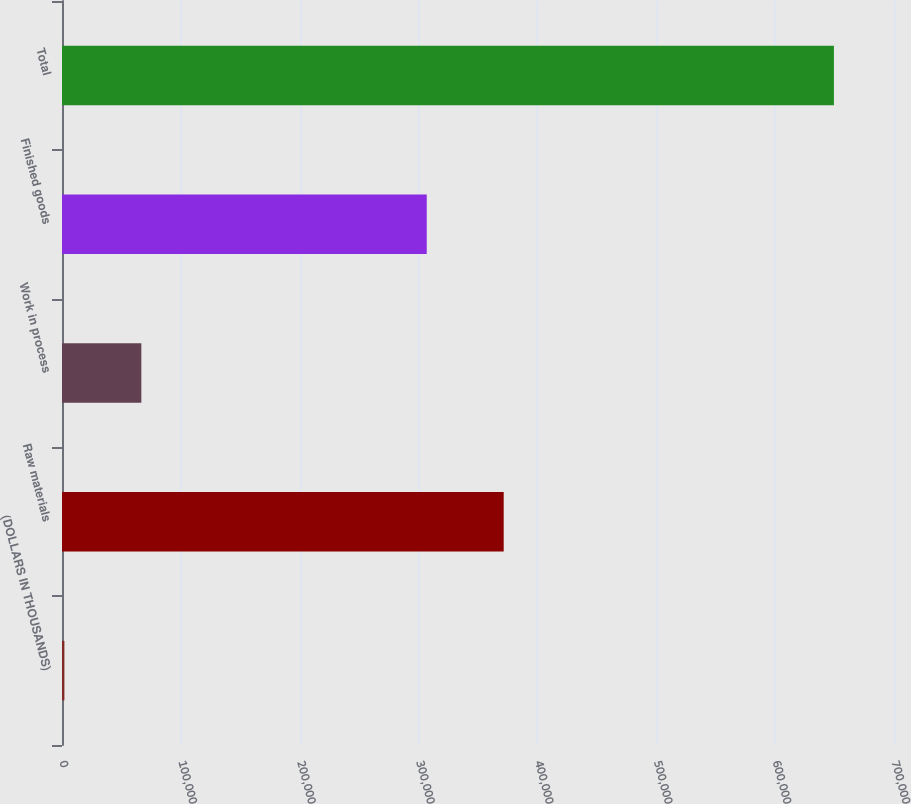<chart> <loc_0><loc_0><loc_500><loc_500><bar_chart><fcel>(DOLLARS IN THOUSANDS)<fcel>Raw materials<fcel>Work in process<fcel>Finished goods<fcel>Total<nl><fcel>2017<fcel>371620<fcel>66760.1<fcel>306877<fcel>649448<nl></chart> 